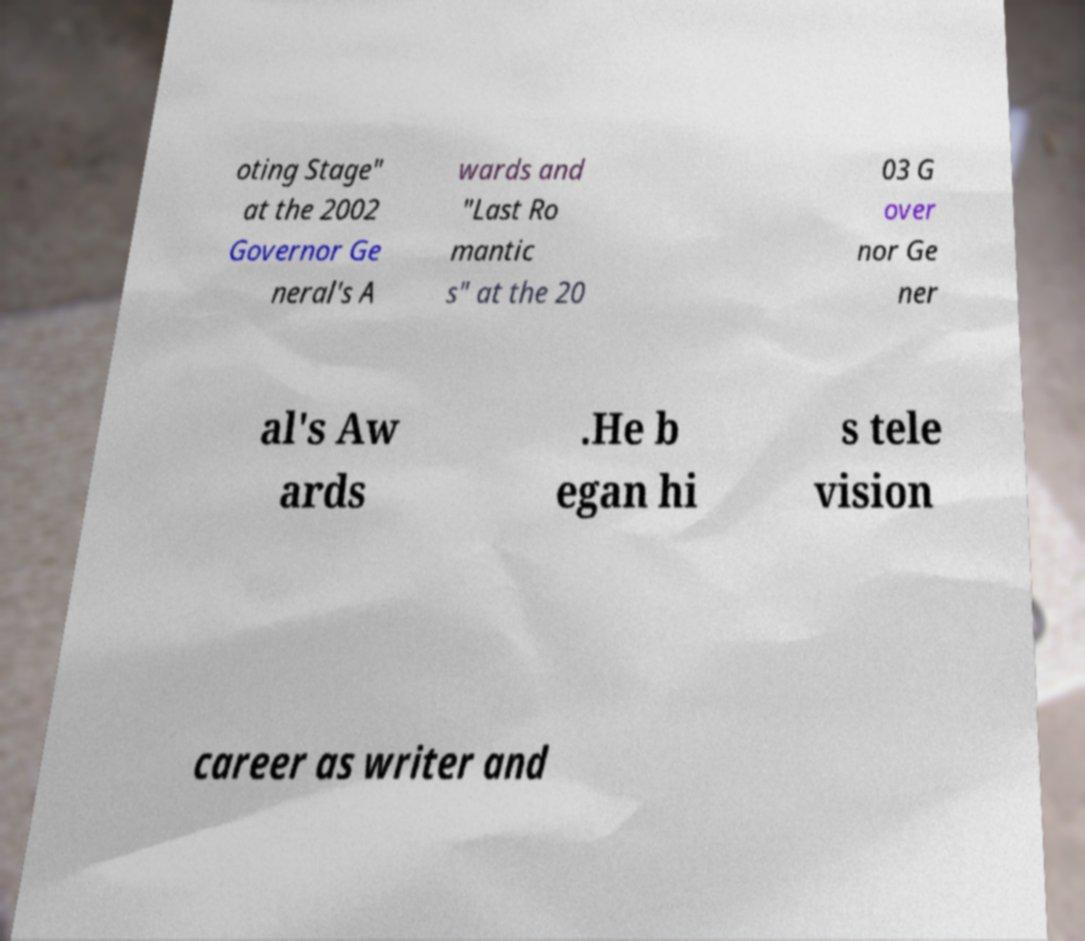Can you accurately transcribe the text from the provided image for me? oting Stage" at the 2002 Governor Ge neral's A wards and "Last Ro mantic s" at the 20 03 G over nor Ge ner al's Aw ards .He b egan hi s tele vision career as writer and 